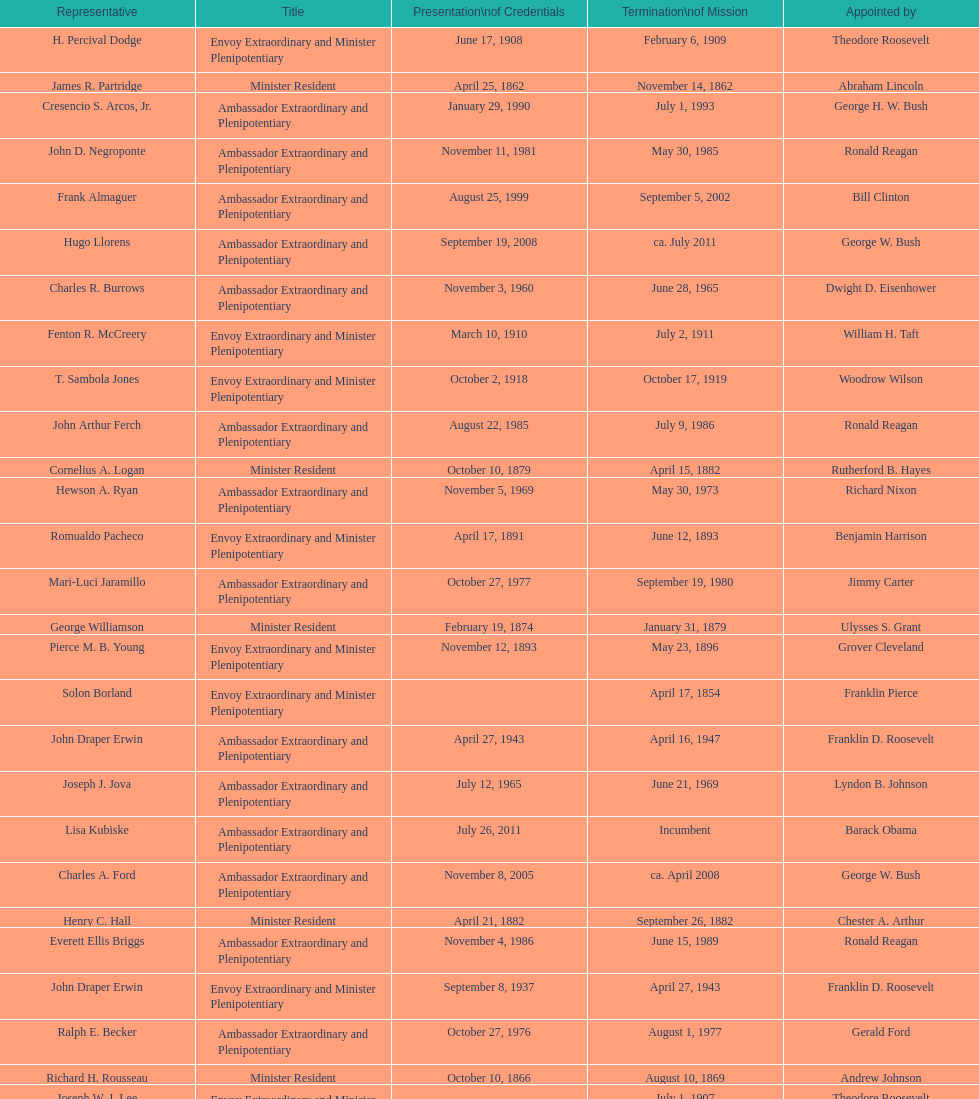Who became the ambassador after the completion of hewson ryan's mission? Phillip V. Sanchez. 